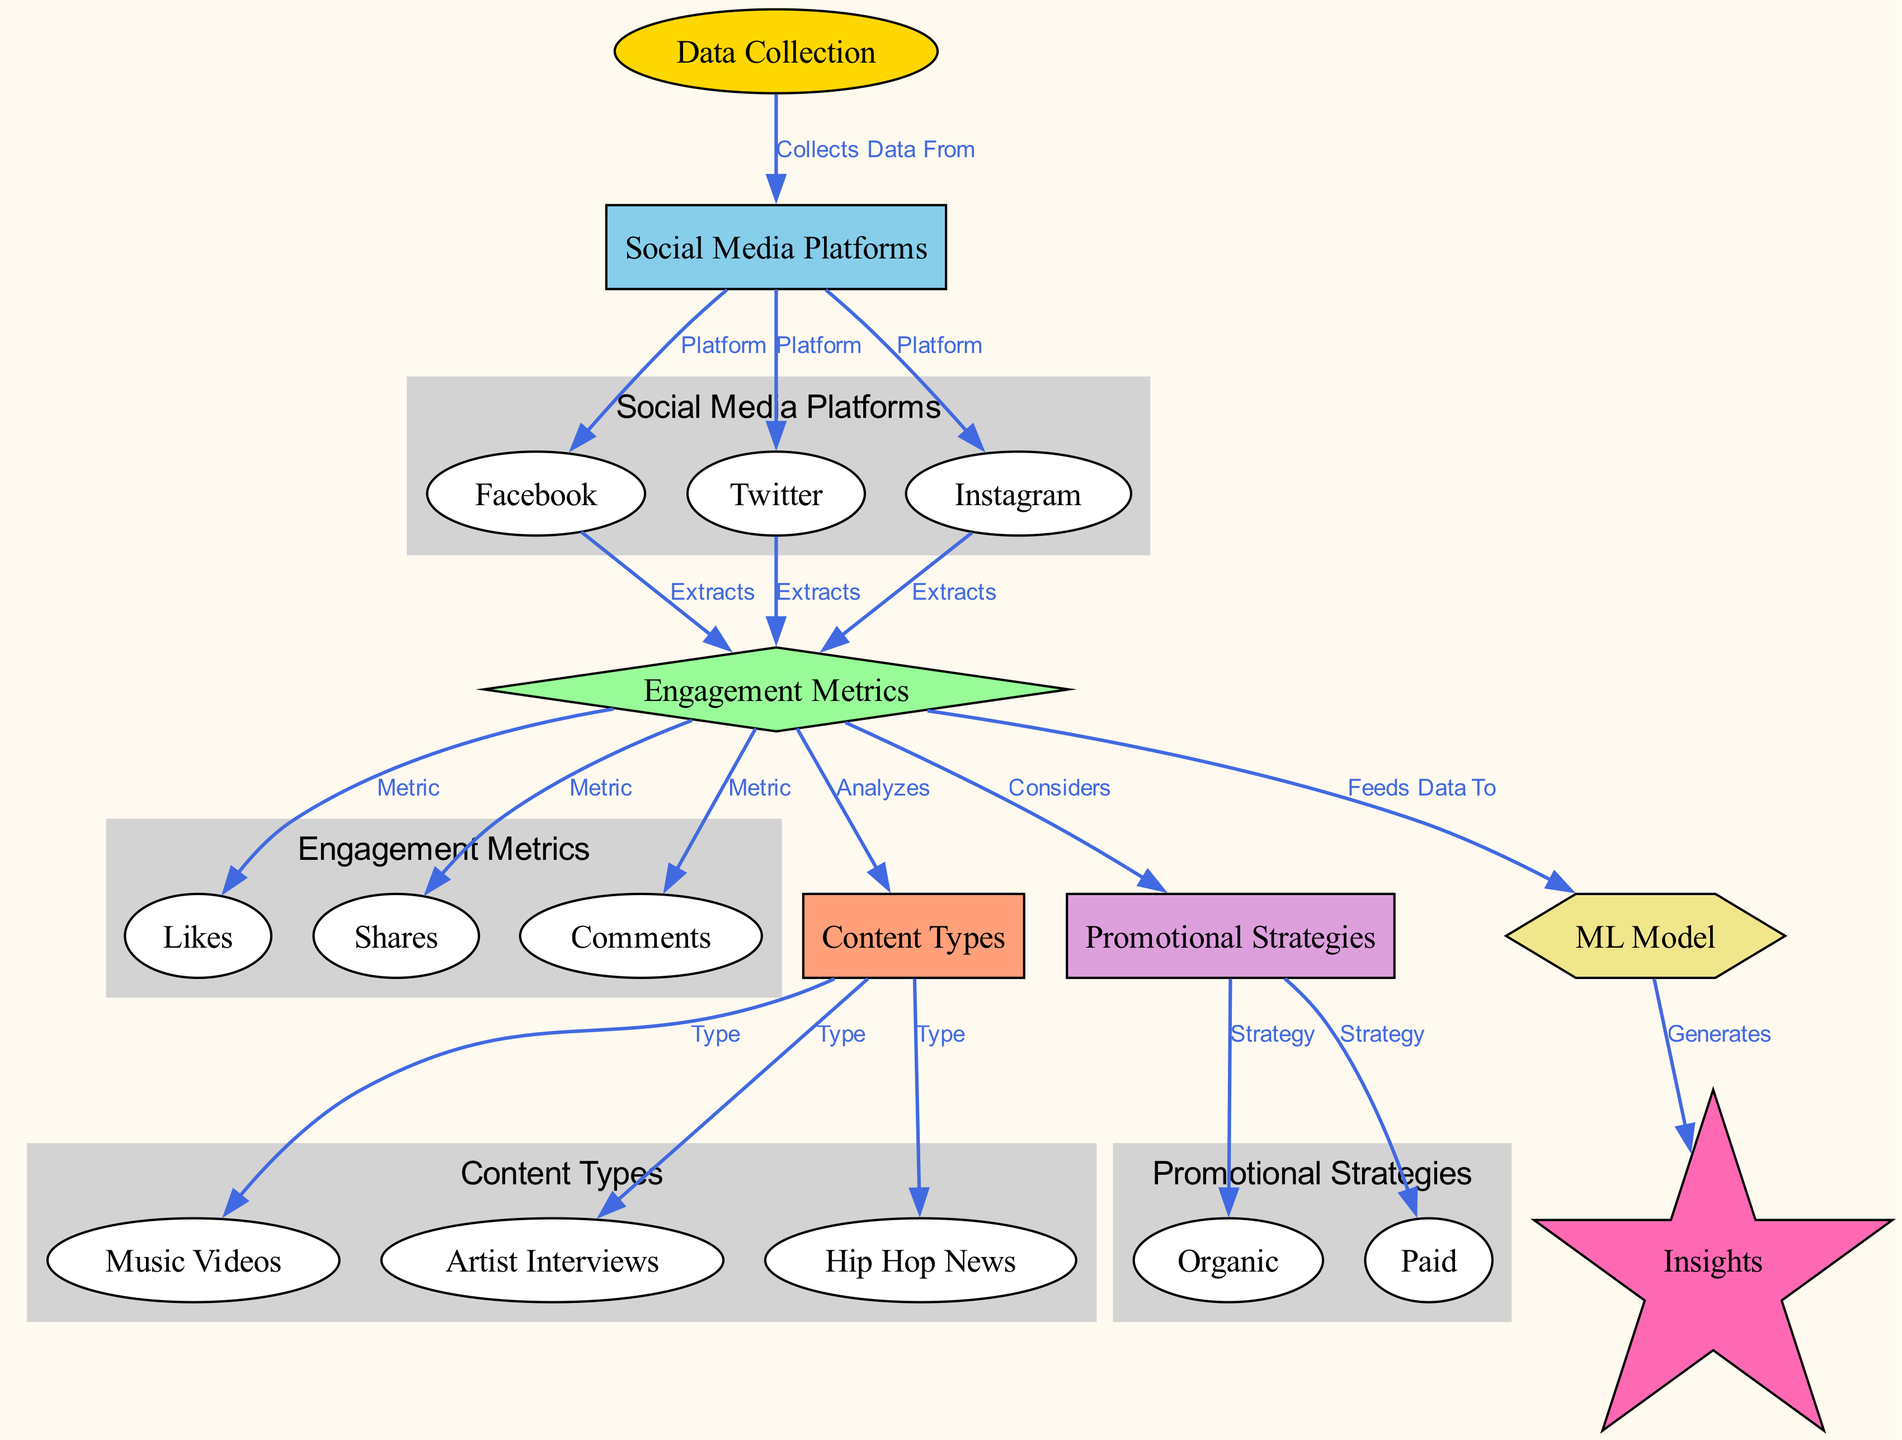What are the three social media platforms listed in the diagram? The diagram explicitly identifies three platforms: Facebook, Twitter, and Instagram, which are connected to the "Social Media Platforms" node.
Answer: Facebook, Twitter, Instagram How many engagement metrics are analyzed in the diagram? The "Engagement Metrics" node directly links to three specific metrics: Likes, Shares, and Comments, suggesting that there are three metrics in total.
Answer: 3 Which content type is connected to the insights generated by the ML model? The "ML Model" node indicates a flow towards the "Insights" node, but it does not specify a singular content type leading to it, hence the relationship is general from the analyzed content types through metrics to insights.
Answer: Insights What type of promotional strategy is noted in the diagram? Two promotional strategies are mentioned under the "Promotional Strategies" node: Organic and Paid, both connected to "Promo Strategies."
Answer: Organic, Paid What data is extracted from the social media platforms? According to the edges from the platform nodes to the "Engagement Metrics" node, the extracted data includes Likes, Shares, and Comments.
Answer: Likes, Shares, Comments Which engagement metric is not mentioned as being connected to content types? The "Content Types" node does not have a direct connection to the "Likes" metric in the diagram, indicating it's not explicitly analyzed in relation to types.
Answer: Likes What is the starting point of the analysis in the diagram? The analysis begins with the "Data Collection" node, which is the first node that collects data and leads to measuring engagement metrics.
Answer: Data Collection How does the ML model contribute to the output of the diagram? The ML Model feeds data from the engagement metrics to generate insights, indicating its role in processing and analyzing the collected data to provide valuable conclusions.
Answer: Generates insights 